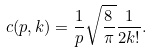<formula> <loc_0><loc_0><loc_500><loc_500>c ( p , k ) = \frac { 1 } { p } \sqrt { \frac { 8 } { \pi } } \frac { 1 } { 2 k ! } .</formula> 